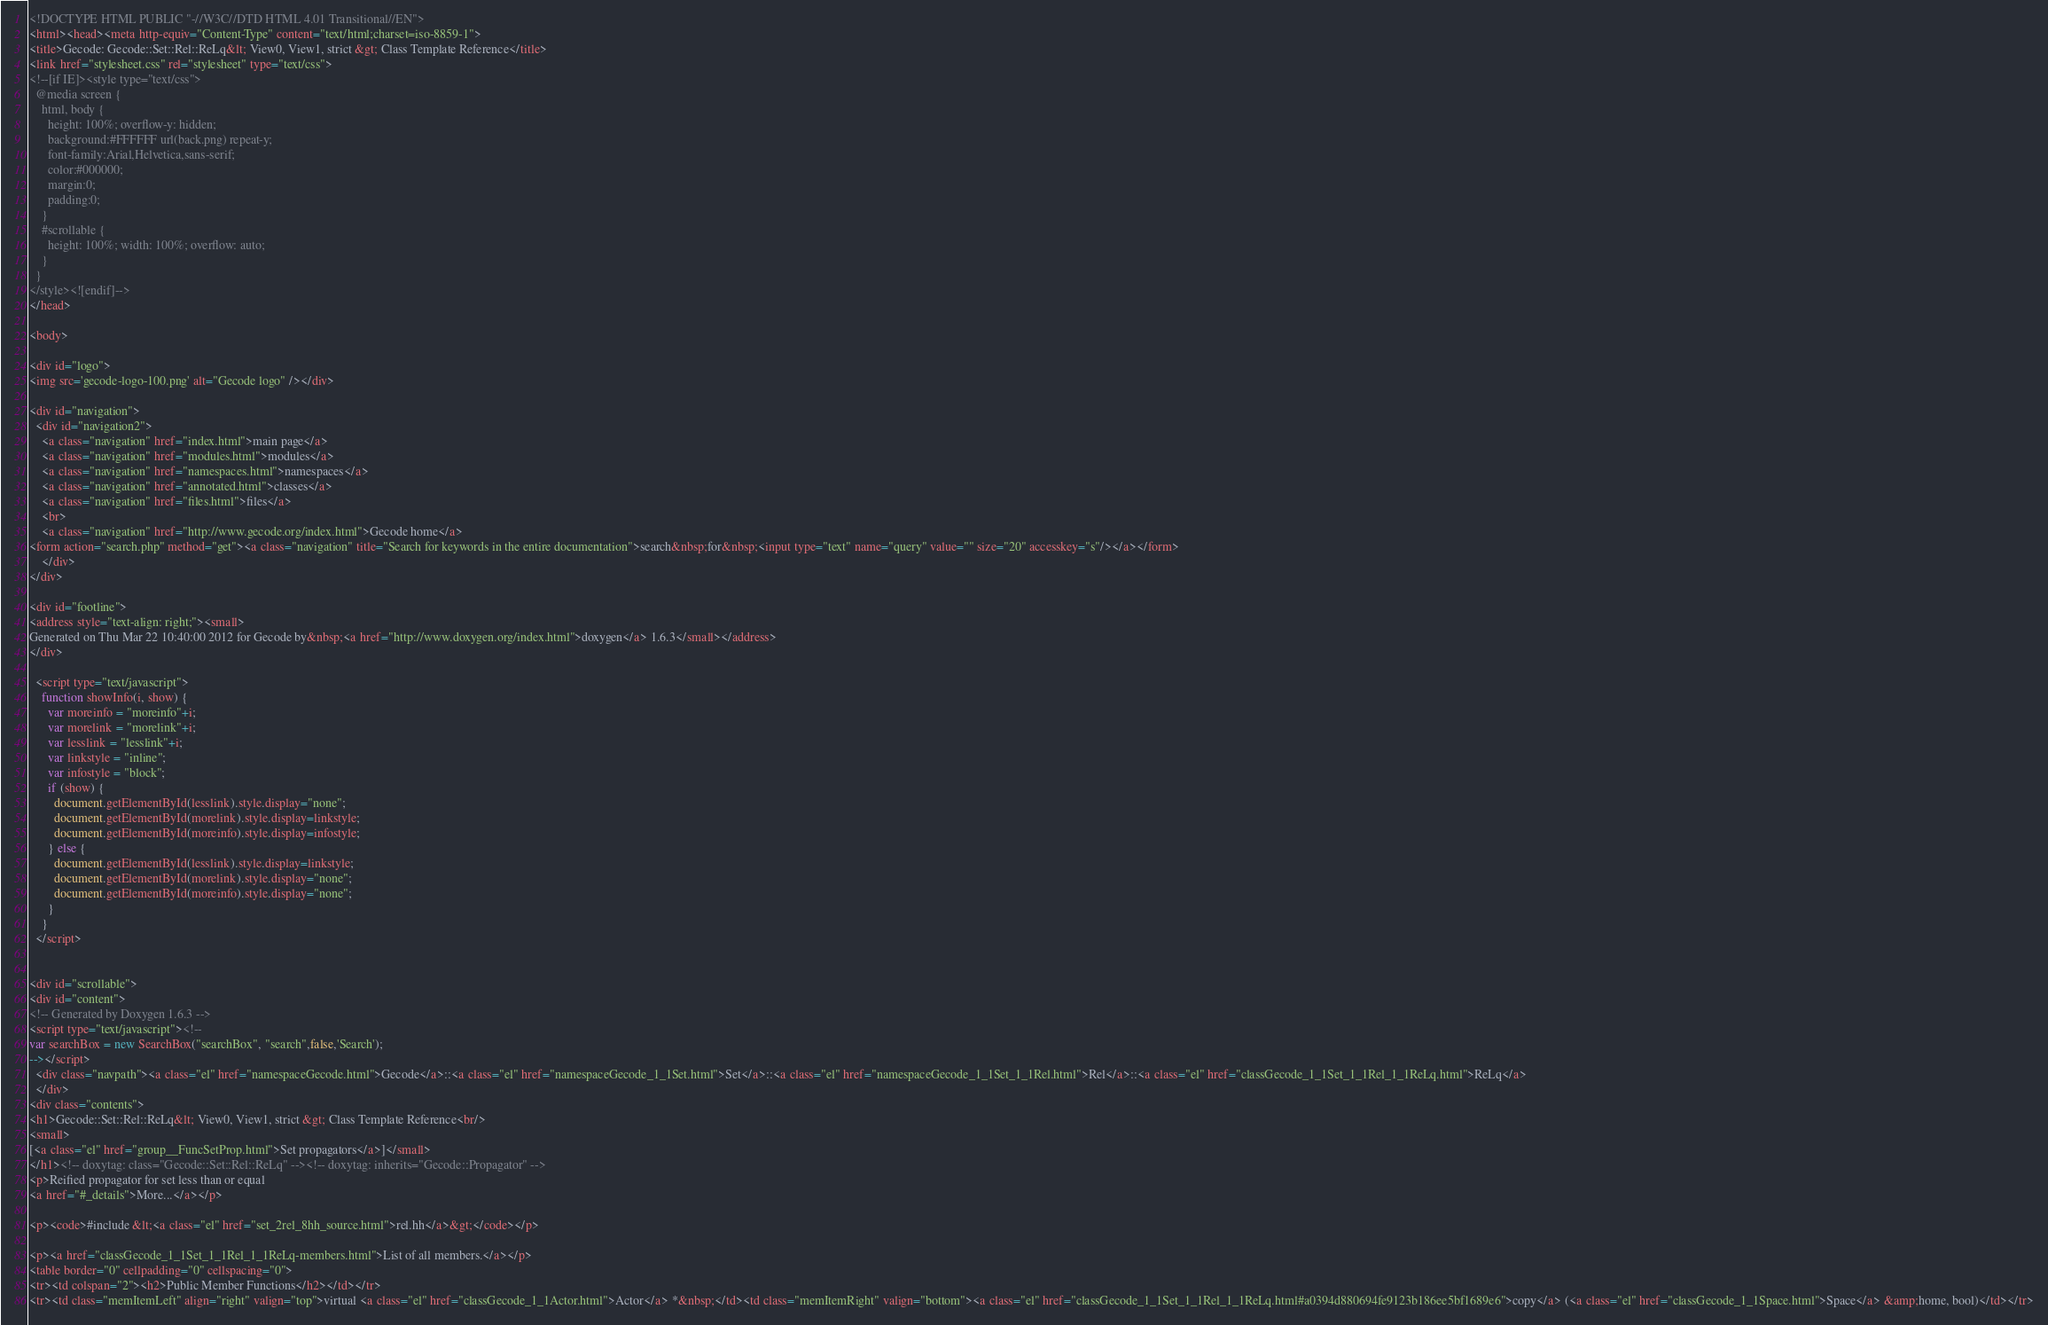Convert code to text. <code><loc_0><loc_0><loc_500><loc_500><_HTML_><!DOCTYPE HTML PUBLIC "-//W3C//DTD HTML 4.01 Transitional//EN">
<html><head><meta http-equiv="Content-Type" content="text/html;charset=iso-8859-1">
<title>Gecode: Gecode::Set::Rel::ReLq&lt; View0, View1, strict &gt; Class Template Reference</title>
<link href="stylesheet.css" rel="stylesheet" type="text/css">
<!--[if IE]><style type="text/css">
  @media screen {
    html, body {
      height: 100%; overflow-y: hidden;
      background:#FFFFFF url(back.png) repeat-y;
      font-family:Arial,Helvetica,sans-serif;
      color:#000000;
      margin:0;
      padding:0;
    }
    #scrollable {
      height: 100%; width: 100%; overflow: auto;
    }
  }
</style><![endif]-->
</head>

<body>

<div id="logo">
<img src='gecode-logo-100.png' alt="Gecode logo" /></div>

<div id="navigation">
  <div id="navigation2">
    <a class="navigation" href="index.html">main page</a>
    <a class="navigation" href="modules.html">modules</a>
    <a class="navigation" href="namespaces.html">namespaces</a>
    <a class="navigation" href="annotated.html">classes</a>
    <a class="navigation" href="files.html">files</a>
    <br>
    <a class="navigation" href="http://www.gecode.org/index.html">Gecode home</a>
<form action="search.php" method="get"><a class="navigation" title="Search for keywords in the entire documentation">search&nbsp;for&nbsp;<input type="text" name="query" value="" size="20" accesskey="s"/></a></form>
    </div>
</div>

<div id="footline">
<address style="text-align: right;"><small>
Generated on Thu Mar 22 10:40:00 2012 for Gecode by&nbsp;<a href="http://www.doxygen.org/index.html">doxygen</a> 1.6.3</small></address>
</div>

  <script type="text/javascript">
    function showInfo(i, show) {
      var moreinfo = "moreinfo"+i;
      var morelink = "morelink"+i;
      var lesslink = "lesslink"+i;
      var linkstyle = "inline";
      var infostyle = "block";
      if (show) {
        document.getElementById(lesslink).style.display="none";
        document.getElementById(morelink).style.display=linkstyle;
        document.getElementById(moreinfo).style.display=infostyle;
      } else {
        document.getElementById(lesslink).style.display=linkstyle;        
        document.getElementById(morelink).style.display="none";        
        document.getElementById(moreinfo).style.display="none";        
      }
    }
  </script>


<div id="scrollable">
<div id="content">
<!-- Generated by Doxygen 1.6.3 -->
<script type="text/javascript"><!--
var searchBox = new SearchBox("searchBox", "search",false,'Search');
--></script>
  <div class="navpath"><a class="el" href="namespaceGecode.html">Gecode</a>::<a class="el" href="namespaceGecode_1_1Set.html">Set</a>::<a class="el" href="namespaceGecode_1_1Set_1_1Rel.html">Rel</a>::<a class="el" href="classGecode_1_1Set_1_1Rel_1_1ReLq.html">ReLq</a>
  </div>
<div class="contents">
<h1>Gecode::Set::Rel::ReLq&lt; View0, View1, strict &gt; Class Template Reference<br/>
<small>
[<a class="el" href="group__FuncSetProp.html">Set propagators</a>]</small>
</h1><!-- doxytag: class="Gecode::Set::Rel::ReLq" --><!-- doxytag: inherits="Gecode::Propagator" -->
<p>Reified propagator for set less than or equal  
<a href="#_details">More...</a></p>

<p><code>#include &lt;<a class="el" href="set_2rel_8hh_source.html">rel.hh</a>&gt;</code></p>

<p><a href="classGecode_1_1Set_1_1Rel_1_1ReLq-members.html">List of all members.</a></p>
<table border="0" cellpadding="0" cellspacing="0">
<tr><td colspan="2"><h2>Public Member Functions</h2></td></tr>
<tr><td class="memItemLeft" align="right" valign="top">virtual <a class="el" href="classGecode_1_1Actor.html">Actor</a> *&nbsp;</td><td class="memItemRight" valign="bottom"><a class="el" href="classGecode_1_1Set_1_1Rel_1_1ReLq.html#a0394d880694fe9123b186ee5bf1689e6">copy</a> (<a class="el" href="classGecode_1_1Space.html">Space</a> &amp;home, bool)</td></tr></code> 